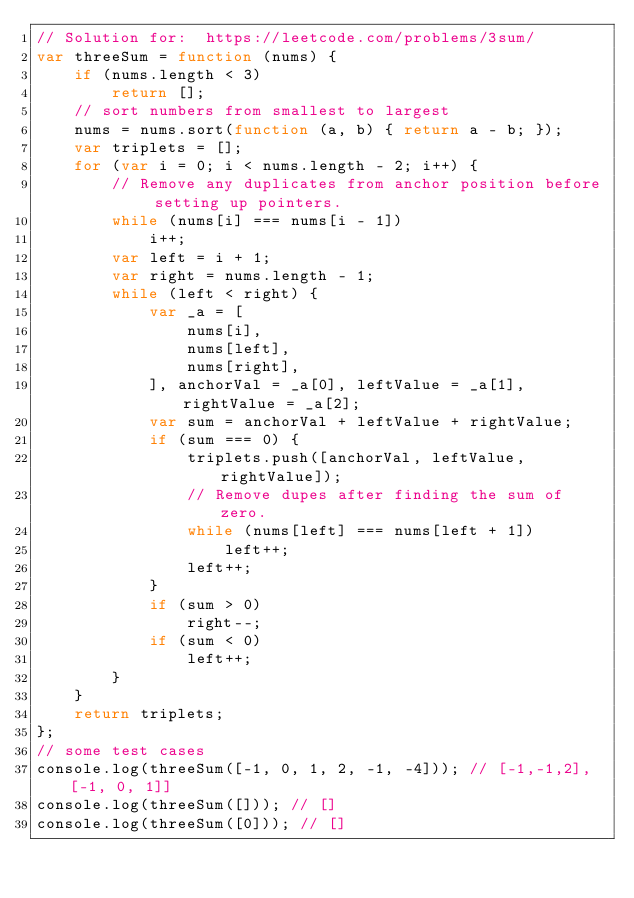<code> <loc_0><loc_0><loc_500><loc_500><_JavaScript_>// Solution for:  https://leetcode.com/problems/3sum/
var threeSum = function (nums) {
    if (nums.length < 3)
        return [];
    // sort numbers from smallest to largest
    nums = nums.sort(function (a, b) { return a - b; });
    var triplets = [];
    for (var i = 0; i < nums.length - 2; i++) {
        // Remove any duplicates from anchor position before setting up pointers.
        while (nums[i] === nums[i - 1])
            i++;
        var left = i + 1;
        var right = nums.length - 1;
        while (left < right) {
            var _a = [
                nums[i],
                nums[left],
                nums[right],
            ], anchorVal = _a[0], leftValue = _a[1], rightValue = _a[2];
            var sum = anchorVal + leftValue + rightValue;
            if (sum === 0) {
                triplets.push([anchorVal, leftValue, rightValue]);
                // Remove dupes after finding the sum of zero.
                while (nums[left] === nums[left + 1])
                    left++;
                left++;
            }
            if (sum > 0)
                right--;
            if (sum < 0)
                left++;
        }
    }
    return triplets;
};
// some test cases
console.log(threeSum([-1, 0, 1, 2, -1, -4])); // [-1,-1,2], [-1, 0, 1]]
console.log(threeSum([])); // []
console.log(threeSum([0])); // []
</code> 